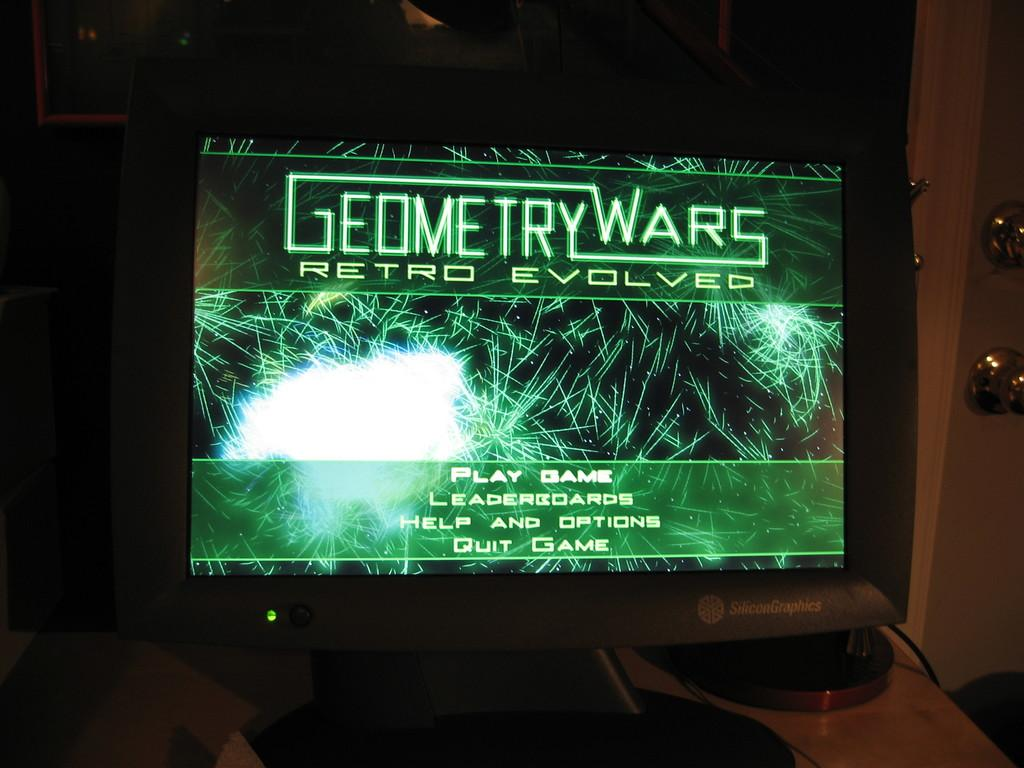<image>
Provide a brief description of the given image. Computer monitor screen showing a green screen that says "Geometry Wars". 